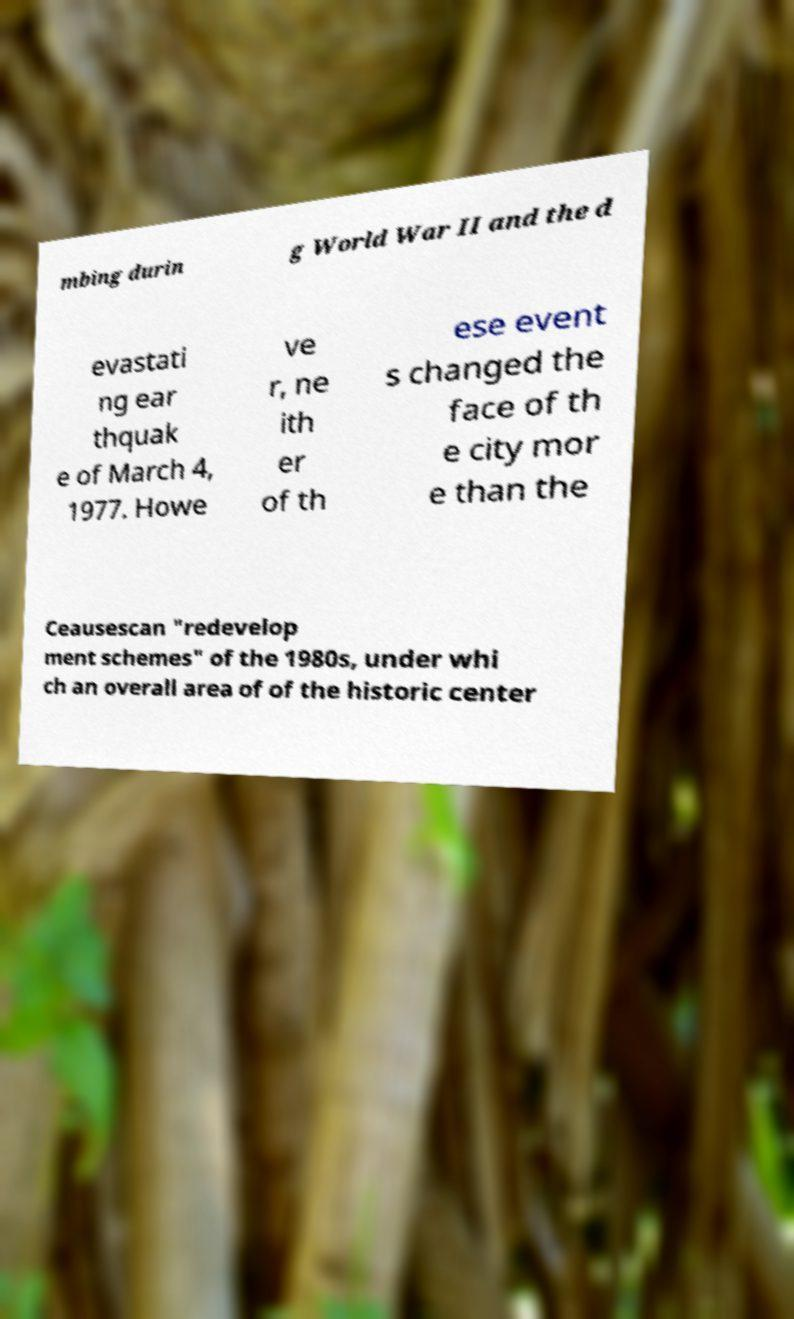Please read and relay the text visible in this image. What does it say? mbing durin g World War II and the d evastati ng ear thquak e of March 4, 1977. Howe ve r, ne ith er of th ese event s changed the face of th e city mor e than the Ceausescan "redevelop ment schemes" of the 1980s, under whi ch an overall area of of the historic center 